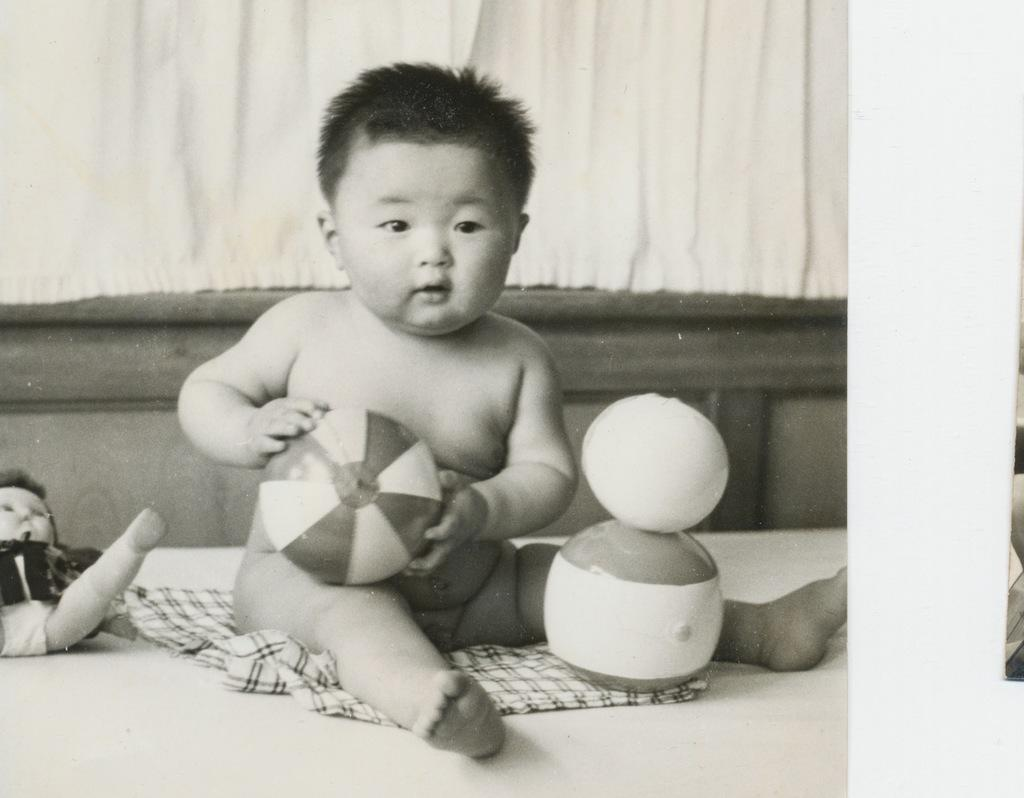Who is the main subject in the image? There is a boy in the center of the image. Where is the boy located? The boy is on a bed. What other object can be seen in the image? There is a toy in the image. What color is the curtain in the background of the image? There is a white color curtain in the background of the image. What type of quarter is the boy offering to the toy in the image? There is no quarter or offering present in the image; it only features a boy on a bed with a toy. 